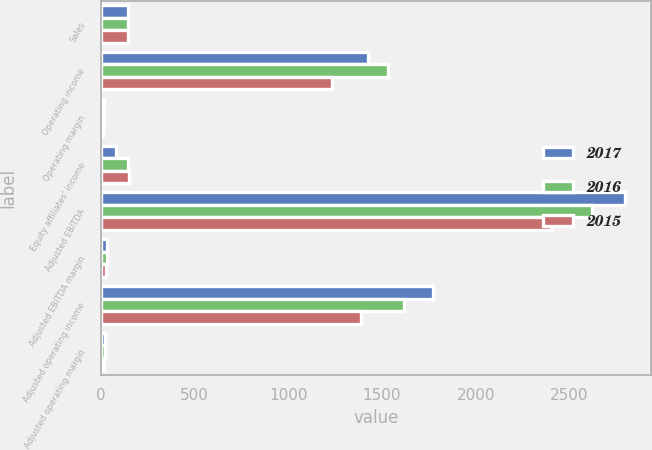Convert chart. <chart><loc_0><loc_0><loc_500><loc_500><stacked_bar_chart><ecel><fcel>Sales<fcel>Operating income<fcel>Operating margin<fcel>Equity affiliates' income<fcel>Adjusted EBITDA<fcel>Adjusted EBITDA margin<fcel>Adjusted operating income<fcel>Adjusted operating margin<nl><fcel>2017<fcel>147<fcel>1427.6<fcel>17.4<fcel>80.1<fcel>2795<fcel>34.1<fcel>1769.6<fcel>21.6<nl><fcel>2016<fcel>147<fcel>1529.7<fcel>20.4<fcel>147<fcel>2621.5<fcel>34.9<fcel>1619.9<fcel>21.6<nl><fcel>2015<fcel>147<fcel>1233.2<fcel>15.8<fcel>152.3<fcel>2399.4<fcel>30.7<fcel>1388.6<fcel>17.7<nl></chart> 